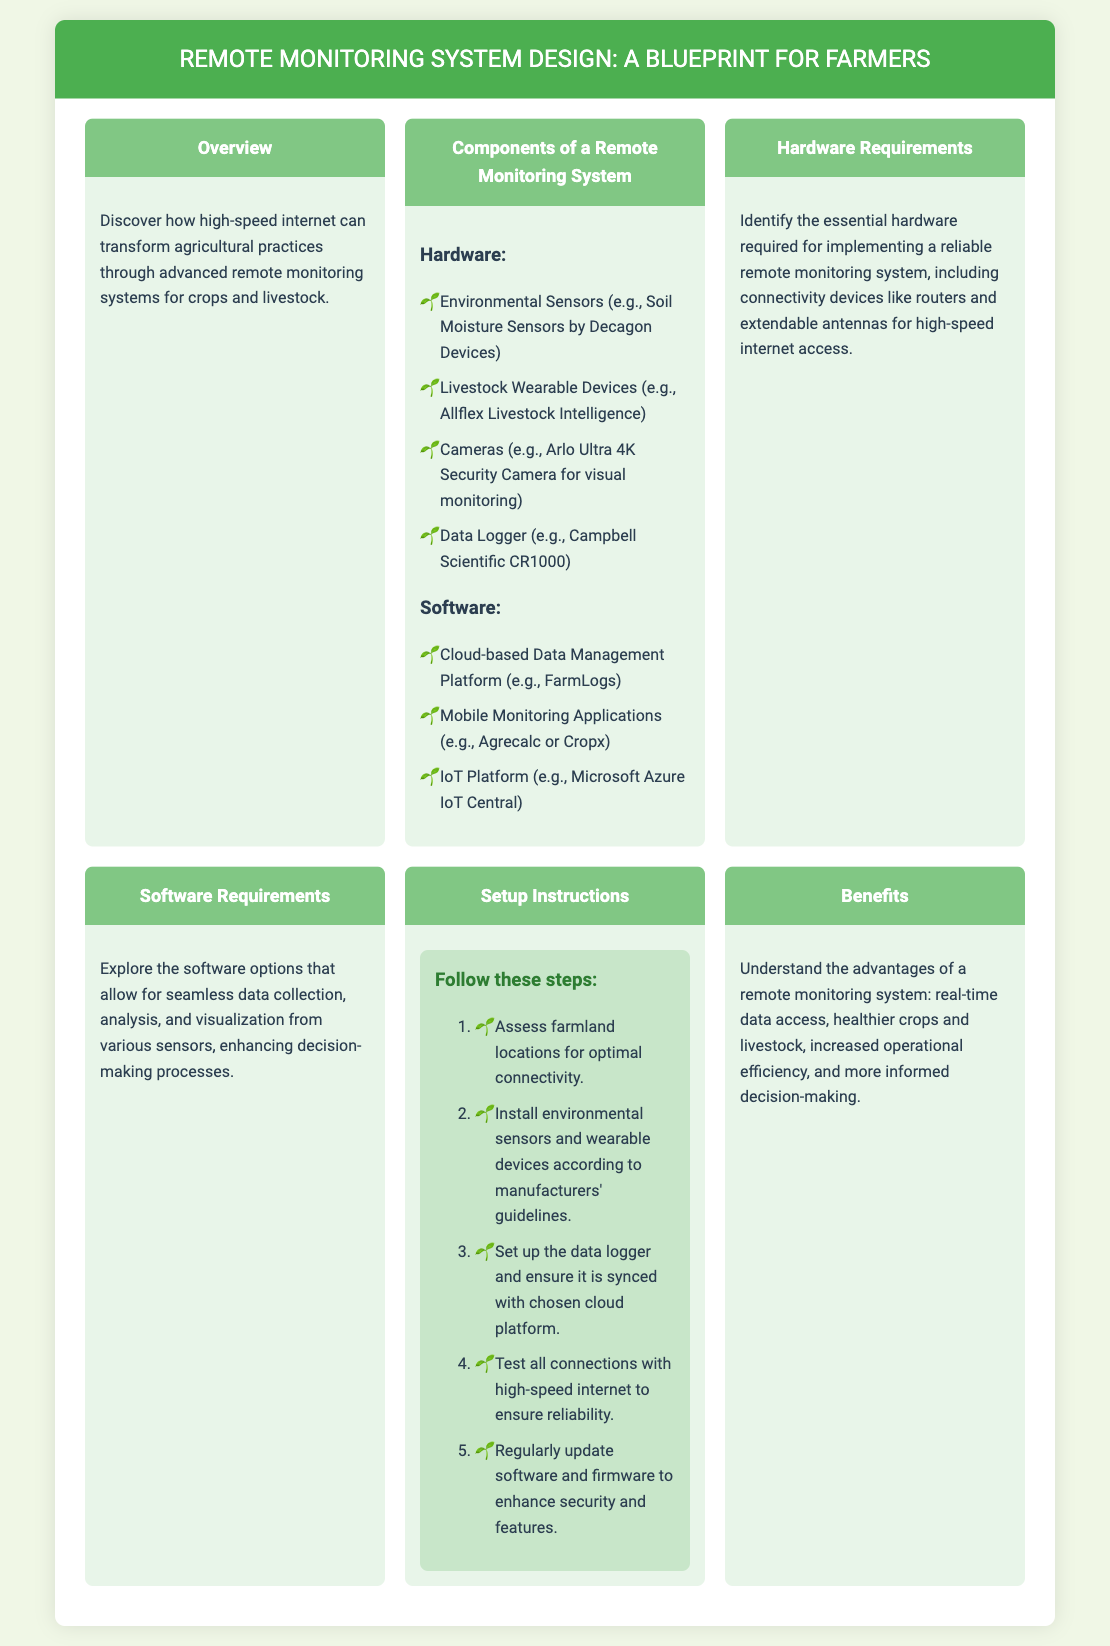What is the main purpose of the document? The document outlines how high-speed internet can improve agricultural practices through remote monitoring systems.
Answer: Remote monitoring systems What are two examples of environmental sensors listed? The document provides specific examples of hardware, including environmental sensors such as soil moisture sensors.
Answer: Soil Moisture Sensors, Allflex Livestock Intelligence How many steps are in the setup instructions? The setup instructions section includes a concise list of steps outlined in an ordered list.
Answer: Five steps What type of cloud-based data management platform is mentioned? The document specifies a cloud-based platform that is suitable for farmers.
Answer: FarmLogs What benefit is associated with a remote monitoring system? The document highlights several advantages of implementing such systems in agriculture.
Answer: Real-time data access What is one type of livestock wearable device mentioned? The document enumerates various devices used for monitoring livestock.
Answer: Allflex Livestock Intelligence Which software allows for seamless data collection? The software requirements section indicates a specific solution for data gathering.
Answer: FarmLogs What color is used for the header background? The header of the document has a specified background color.
Answer: Green 